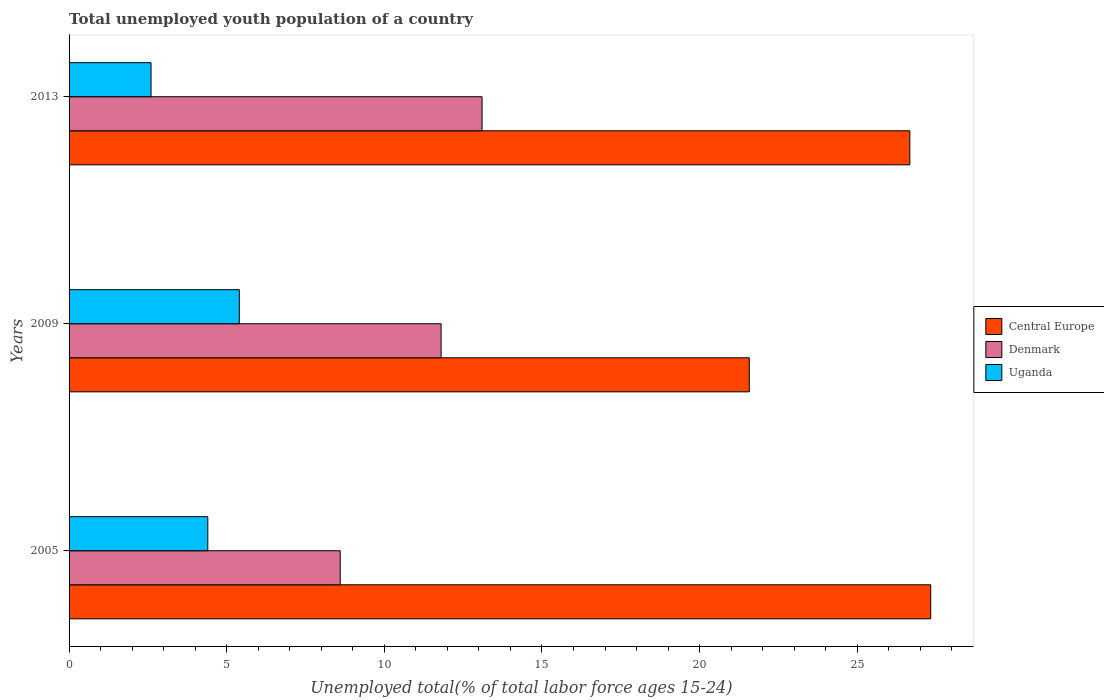How many bars are there on the 2nd tick from the bottom?
Offer a very short reply. 3. What is the label of the 1st group of bars from the top?
Ensure brevity in your answer.  2013. In how many cases, is the number of bars for a given year not equal to the number of legend labels?
Provide a succinct answer. 0. What is the percentage of total unemployed youth population of a country in Central Europe in 2013?
Keep it short and to the point. 26.67. Across all years, what is the maximum percentage of total unemployed youth population of a country in Denmark?
Provide a succinct answer. 13.1. Across all years, what is the minimum percentage of total unemployed youth population of a country in Uganda?
Your response must be concise. 2.6. In which year was the percentage of total unemployed youth population of a country in Uganda maximum?
Keep it short and to the point. 2009. In which year was the percentage of total unemployed youth population of a country in Denmark minimum?
Offer a very short reply. 2005. What is the total percentage of total unemployed youth population of a country in Denmark in the graph?
Offer a terse response. 33.5. What is the difference between the percentage of total unemployed youth population of a country in Uganda in 2005 and that in 2009?
Make the answer very short. -1. What is the difference between the percentage of total unemployed youth population of a country in Central Europe in 2005 and the percentage of total unemployed youth population of a country in Denmark in 2009?
Your answer should be compact. 15.53. What is the average percentage of total unemployed youth population of a country in Uganda per year?
Ensure brevity in your answer.  4.13. In the year 2009, what is the difference between the percentage of total unemployed youth population of a country in Uganda and percentage of total unemployed youth population of a country in Denmark?
Provide a succinct answer. -6.4. In how many years, is the percentage of total unemployed youth population of a country in Uganda greater than 12 %?
Ensure brevity in your answer.  0. What is the ratio of the percentage of total unemployed youth population of a country in Central Europe in 2005 to that in 2009?
Make the answer very short. 1.27. What is the difference between the highest and the second highest percentage of total unemployed youth population of a country in Central Europe?
Provide a succinct answer. 0.66. What is the difference between the highest and the lowest percentage of total unemployed youth population of a country in Denmark?
Your response must be concise. 4.5. In how many years, is the percentage of total unemployed youth population of a country in Uganda greater than the average percentage of total unemployed youth population of a country in Uganda taken over all years?
Offer a very short reply. 2. What does the 1st bar from the top in 2005 represents?
Keep it short and to the point. Uganda. What does the 1st bar from the bottom in 2013 represents?
Your answer should be very brief. Central Europe. Is it the case that in every year, the sum of the percentage of total unemployed youth population of a country in Uganda and percentage of total unemployed youth population of a country in Denmark is greater than the percentage of total unemployed youth population of a country in Central Europe?
Give a very brief answer. No. What is the title of the graph?
Ensure brevity in your answer.  Total unemployed youth population of a country. What is the label or title of the X-axis?
Keep it short and to the point. Unemployed total(% of total labor force ages 15-24). What is the Unemployed total(% of total labor force ages 15-24) of Central Europe in 2005?
Make the answer very short. 27.33. What is the Unemployed total(% of total labor force ages 15-24) in Denmark in 2005?
Your response must be concise. 8.6. What is the Unemployed total(% of total labor force ages 15-24) of Uganda in 2005?
Your answer should be very brief. 4.4. What is the Unemployed total(% of total labor force ages 15-24) of Central Europe in 2009?
Make the answer very short. 21.58. What is the Unemployed total(% of total labor force ages 15-24) of Denmark in 2009?
Ensure brevity in your answer.  11.8. What is the Unemployed total(% of total labor force ages 15-24) in Uganda in 2009?
Provide a short and direct response. 5.4. What is the Unemployed total(% of total labor force ages 15-24) in Central Europe in 2013?
Make the answer very short. 26.67. What is the Unemployed total(% of total labor force ages 15-24) in Denmark in 2013?
Offer a terse response. 13.1. What is the Unemployed total(% of total labor force ages 15-24) in Uganda in 2013?
Give a very brief answer. 2.6. Across all years, what is the maximum Unemployed total(% of total labor force ages 15-24) in Central Europe?
Offer a terse response. 27.33. Across all years, what is the maximum Unemployed total(% of total labor force ages 15-24) in Denmark?
Offer a terse response. 13.1. Across all years, what is the maximum Unemployed total(% of total labor force ages 15-24) in Uganda?
Make the answer very short. 5.4. Across all years, what is the minimum Unemployed total(% of total labor force ages 15-24) in Central Europe?
Offer a terse response. 21.58. Across all years, what is the minimum Unemployed total(% of total labor force ages 15-24) in Denmark?
Provide a succinct answer. 8.6. Across all years, what is the minimum Unemployed total(% of total labor force ages 15-24) in Uganda?
Make the answer very short. 2.6. What is the total Unemployed total(% of total labor force ages 15-24) of Central Europe in the graph?
Offer a terse response. 75.57. What is the total Unemployed total(% of total labor force ages 15-24) of Denmark in the graph?
Give a very brief answer. 33.5. What is the difference between the Unemployed total(% of total labor force ages 15-24) of Central Europe in 2005 and that in 2009?
Your answer should be very brief. 5.75. What is the difference between the Unemployed total(% of total labor force ages 15-24) of Denmark in 2005 and that in 2009?
Your answer should be very brief. -3.2. What is the difference between the Unemployed total(% of total labor force ages 15-24) of Uganda in 2005 and that in 2009?
Provide a succinct answer. -1. What is the difference between the Unemployed total(% of total labor force ages 15-24) in Central Europe in 2005 and that in 2013?
Provide a succinct answer. 0.66. What is the difference between the Unemployed total(% of total labor force ages 15-24) of Central Europe in 2009 and that in 2013?
Keep it short and to the point. -5.09. What is the difference between the Unemployed total(% of total labor force ages 15-24) in Uganda in 2009 and that in 2013?
Make the answer very short. 2.8. What is the difference between the Unemployed total(% of total labor force ages 15-24) of Central Europe in 2005 and the Unemployed total(% of total labor force ages 15-24) of Denmark in 2009?
Your answer should be compact. 15.53. What is the difference between the Unemployed total(% of total labor force ages 15-24) of Central Europe in 2005 and the Unemployed total(% of total labor force ages 15-24) of Uganda in 2009?
Provide a succinct answer. 21.93. What is the difference between the Unemployed total(% of total labor force ages 15-24) of Central Europe in 2005 and the Unemployed total(% of total labor force ages 15-24) of Denmark in 2013?
Offer a terse response. 14.23. What is the difference between the Unemployed total(% of total labor force ages 15-24) in Central Europe in 2005 and the Unemployed total(% of total labor force ages 15-24) in Uganda in 2013?
Make the answer very short. 24.73. What is the difference between the Unemployed total(% of total labor force ages 15-24) of Central Europe in 2009 and the Unemployed total(% of total labor force ages 15-24) of Denmark in 2013?
Your response must be concise. 8.48. What is the difference between the Unemployed total(% of total labor force ages 15-24) in Central Europe in 2009 and the Unemployed total(% of total labor force ages 15-24) in Uganda in 2013?
Your answer should be very brief. 18.98. What is the average Unemployed total(% of total labor force ages 15-24) in Central Europe per year?
Offer a very short reply. 25.19. What is the average Unemployed total(% of total labor force ages 15-24) of Denmark per year?
Keep it short and to the point. 11.17. What is the average Unemployed total(% of total labor force ages 15-24) in Uganda per year?
Provide a short and direct response. 4.13. In the year 2005, what is the difference between the Unemployed total(% of total labor force ages 15-24) in Central Europe and Unemployed total(% of total labor force ages 15-24) in Denmark?
Your answer should be compact. 18.73. In the year 2005, what is the difference between the Unemployed total(% of total labor force ages 15-24) in Central Europe and Unemployed total(% of total labor force ages 15-24) in Uganda?
Your response must be concise. 22.93. In the year 2009, what is the difference between the Unemployed total(% of total labor force ages 15-24) of Central Europe and Unemployed total(% of total labor force ages 15-24) of Denmark?
Your answer should be compact. 9.78. In the year 2009, what is the difference between the Unemployed total(% of total labor force ages 15-24) of Central Europe and Unemployed total(% of total labor force ages 15-24) of Uganda?
Provide a short and direct response. 16.18. In the year 2013, what is the difference between the Unemployed total(% of total labor force ages 15-24) in Central Europe and Unemployed total(% of total labor force ages 15-24) in Denmark?
Offer a terse response. 13.57. In the year 2013, what is the difference between the Unemployed total(% of total labor force ages 15-24) of Central Europe and Unemployed total(% of total labor force ages 15-24) of Uganda?
Keep it short and to the point. 24.07. In the year 2013, what is the difference between the Unemployed total(% of total labor force ages 15-24) of Denmark and Unemployed total(% of total labor force ages 15-24) of Uganda?
Keep it short and to the point. 10.5. What is the ratio of the Unemployed total(% of total labor force ages 15-24) of Central Europe in 2005 to that in 2009?
Offer a terse response. 1.27. What is the ratio of the Unemployed total(% of total labor force ages 15-24) in Denmark in 2005 to that in 2009?
Make the answer very short. 0.73. What is the ratio of the Unemployed total(% of total labor force ages 15-24) of Uganda in 2005 to that in 2009?
Give a very brief answer. 0.81. What is the ratio of the Unemployed total(% of total labor force ages 15-24) in Central Europe in 2005 to that in 2013?
Make the answer very short. 1.02. What is the ratio of the Unemployed total(% of total labor force ages 15-24) of Denmark in 2005 to that in 2013?
Offer a terse response. 0.66. What is the ratio of the Unemployed total(% of total labor force ages 15-24) in Uganda in 2005 to that in 2013?
Ensure brevity in your answer.  1.69. What is the ratio of the Unemployed total(% of total labor force ages 15-24) of Central Europe in 2009 to that in 2013?
Provide a short and direct response. 0.81. What is the ratio of the Unemployed total(% of total labor force ages 15-24) of Denmark in 2009 to that in 2013?
Offer a terse response. 0.9. What is the ratio of the Unemployed total(% of total labor force ages 15-24) of Uganda in 2009 to that in 2013?
Offer a very short reply. 2.08. What is the difference between the highest and the second highest Unemployed total(% of total labor force ages 15-24) of Central Europe?
Your response must be concise. 0.66. What is the difference between the highest and the second highest Unemployed total(% of total labor force ages 15-24) of Denmark?
Offer a terse response. 1.3. What is the difference between the highest and the second highest Unemployed total(% of total labor force ages 15-24) in Uganda?
Offer a terse response. 1. What is the difference between the highest and the lowest Unemployed total(% of total labor force ages 15-24) in Central Europe?
Provide a short and direct response. 5.75. What is the difference between the highest and the lowest Unemployed total(% of total labor force ages 15-24) in Uganda?
Your response must be concise. 2.8. 